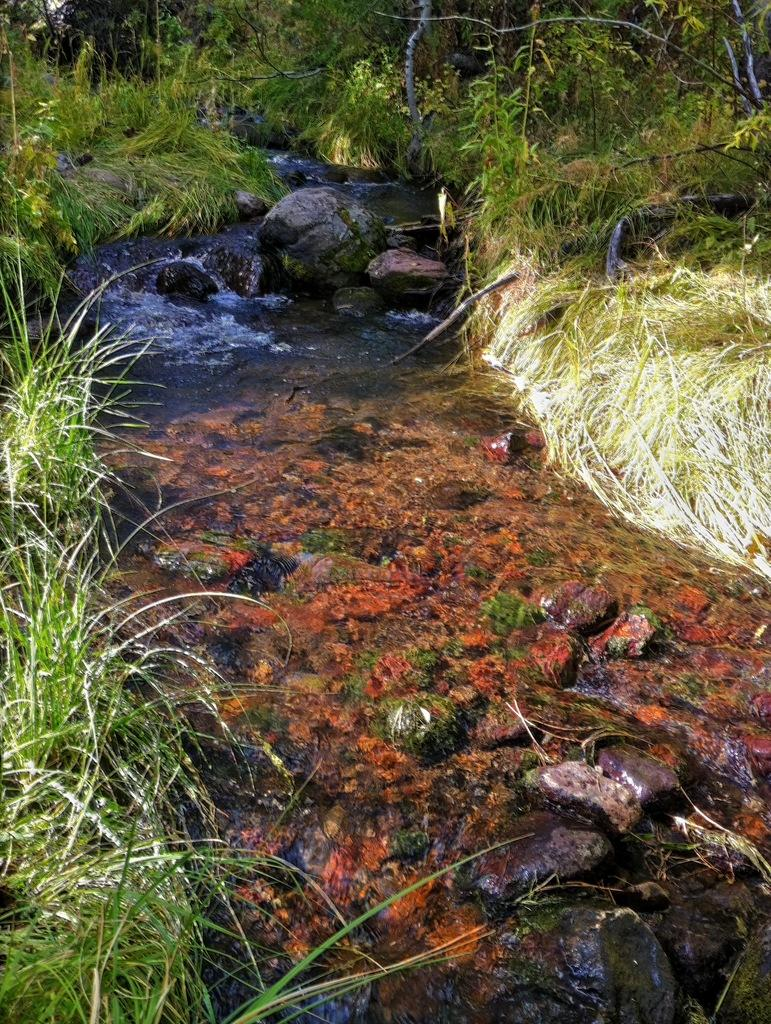What type of natural elements can be seen in the image? There are stones, water, grass, plants, and trees visible in the image. Can you describe the water in the image? The water is visible in the image, but its specific characteristics are not mentioned. What type of vegetation is present in the image? There are plants and trees in the image. What attempt does the porter make to express their love in the image? There is no porter or expression of love present in the image; it features natural elements such as stones, water, grass, plants, and trees. 